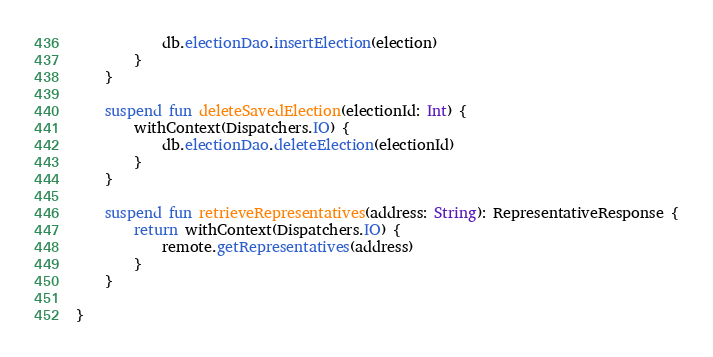Convert code to text. <code><loc_0><loc_0><loc_500><loc_500><_Kotlin_>            db.electionDao.insertElection(election)
        }
    }

    suspend fun deleteSavedElection(electionId: Int) {
        withContext(Dispatchers.IO) {
            db.electionDao.deleteElection(electionId)
        }
    }

    suspend fun retrieveRepresentatives(address: String): RepresentativeResponse {
        return withContext(Dispatchers.IO) {
            remote.getRepresentatives(address)
        }
    }

}</code> 